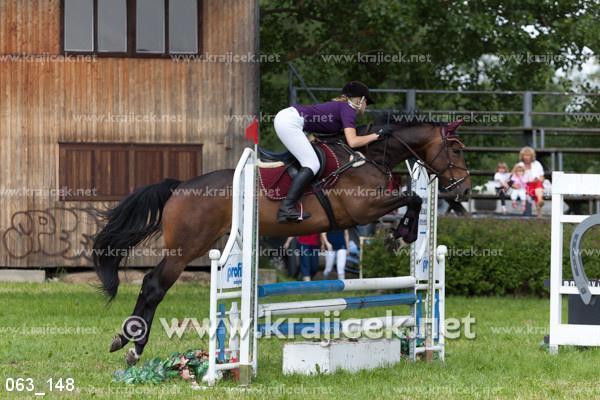What activity is the horse shown here taking part in?
Select the correct answer and articulate reasoning with the following format: 'Answer: answer
Rationale: rationale.'
Options: Steeple chase, racing, barrel racing, roping. Answer: steeple chase.
Rationale: The activity is steeplechase. 